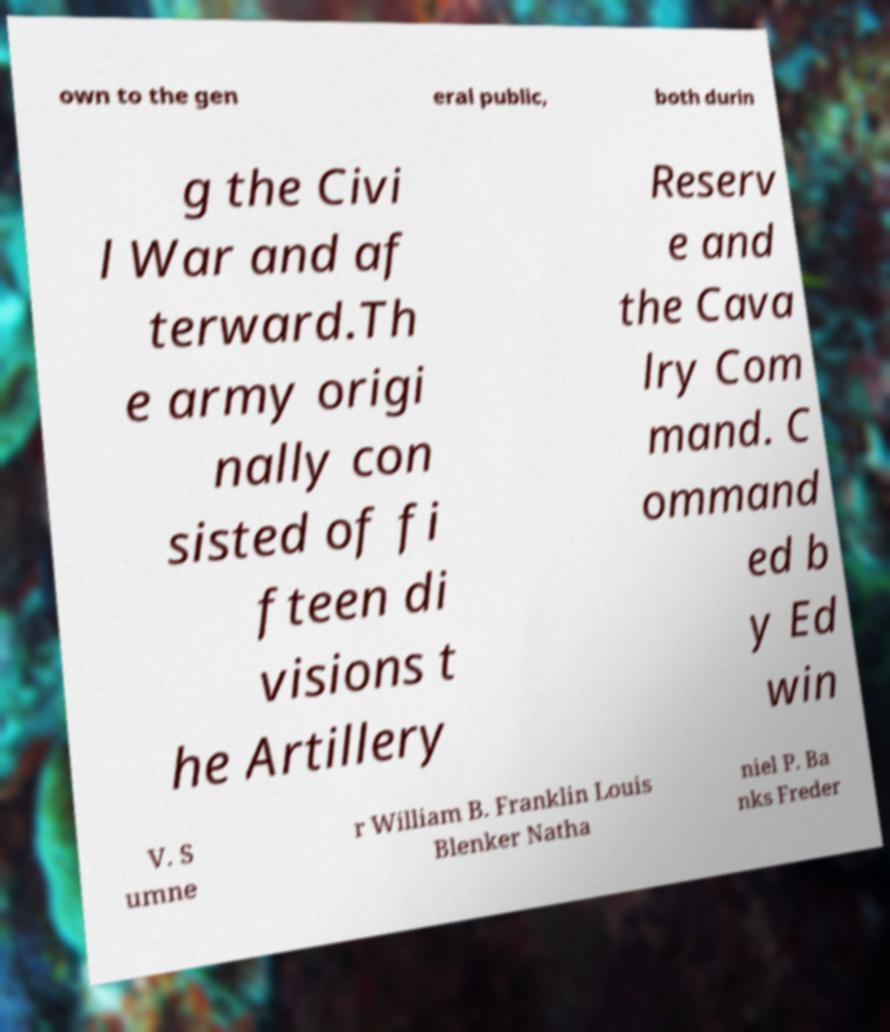For documentation purposes, I need the text within this image transcribed. Could you provide that? own to the gen eral public, both durin g the Civi l War and af terward.Th e army origi nally con sisted of fi fteen di visions t he Artillery Reserv e and the Cava lry Com mand. C ommand ed b y Ed win V. S umne r William B. Franklin Louis Blenker Natha niel P. Ba nks Freder 